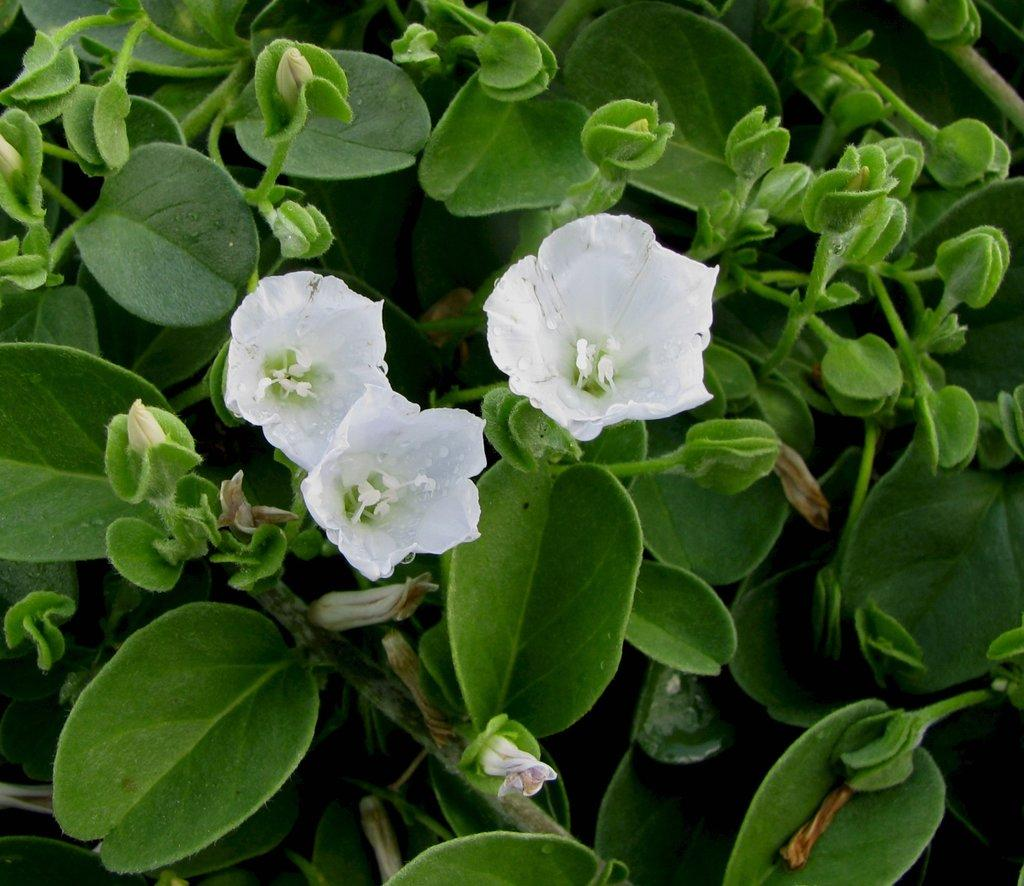What type of plants can be seen in the image? There are flowers in the image. What else can be seen in the background of the image? There are leaves in the background of the image. How many ants are crawling on the boat in the image? There is no boat or ants present in the image; it features flowers and leaves. 